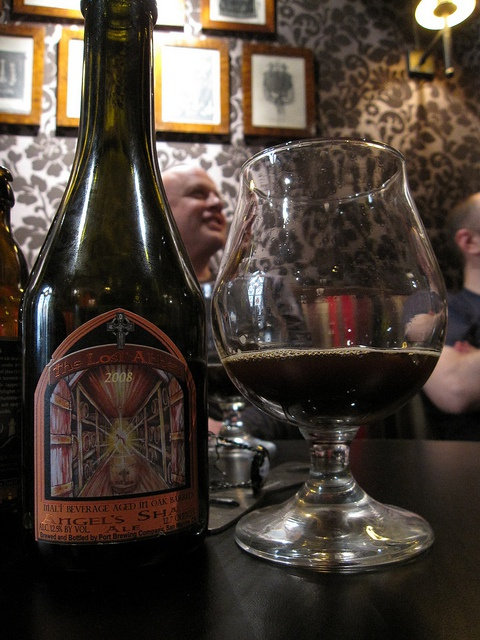Describe the objects in this image and their specific colors. I can see dining table in maroon, black, and gray tones, bottle in maroon, black, and gray tones, wine glass in maroon, black, and gray tones, people in maroon, black, gray, and brown tones, and bottle in maroon, black, gray, and olive tones in this image. 